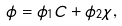Convert formula to latex. <formula><loc_0><loc_0><loc_500><loc_500>\phi = \phi _ { 1 } C + \phi _ { 2 } \chi ,</formula> 